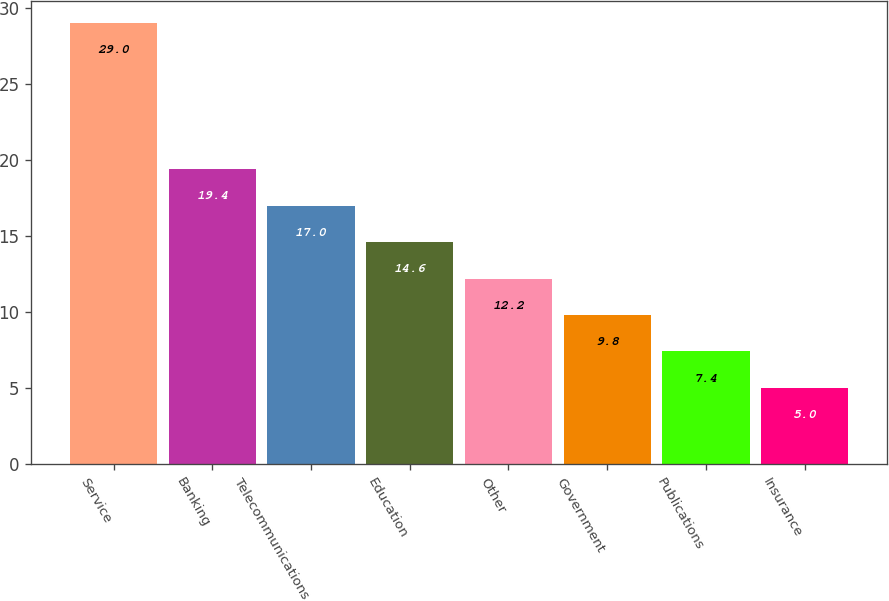Convert chart to OTSL. <chart><loc_0><loc_0><loc_500><loc_500><bar_chart><fcel>Service<fcel>Banking<fcel>Telecommunications<fcel>Education<fcel>Other<fcel>Government<fcel>Publications<fcel>Insurance<nl><fcel>29<fcel>19.4<fcel>17<fcel>14.6<fcel>12.2<fcel>9.8<fcel>7.4<fcel>5<nl></chart> 